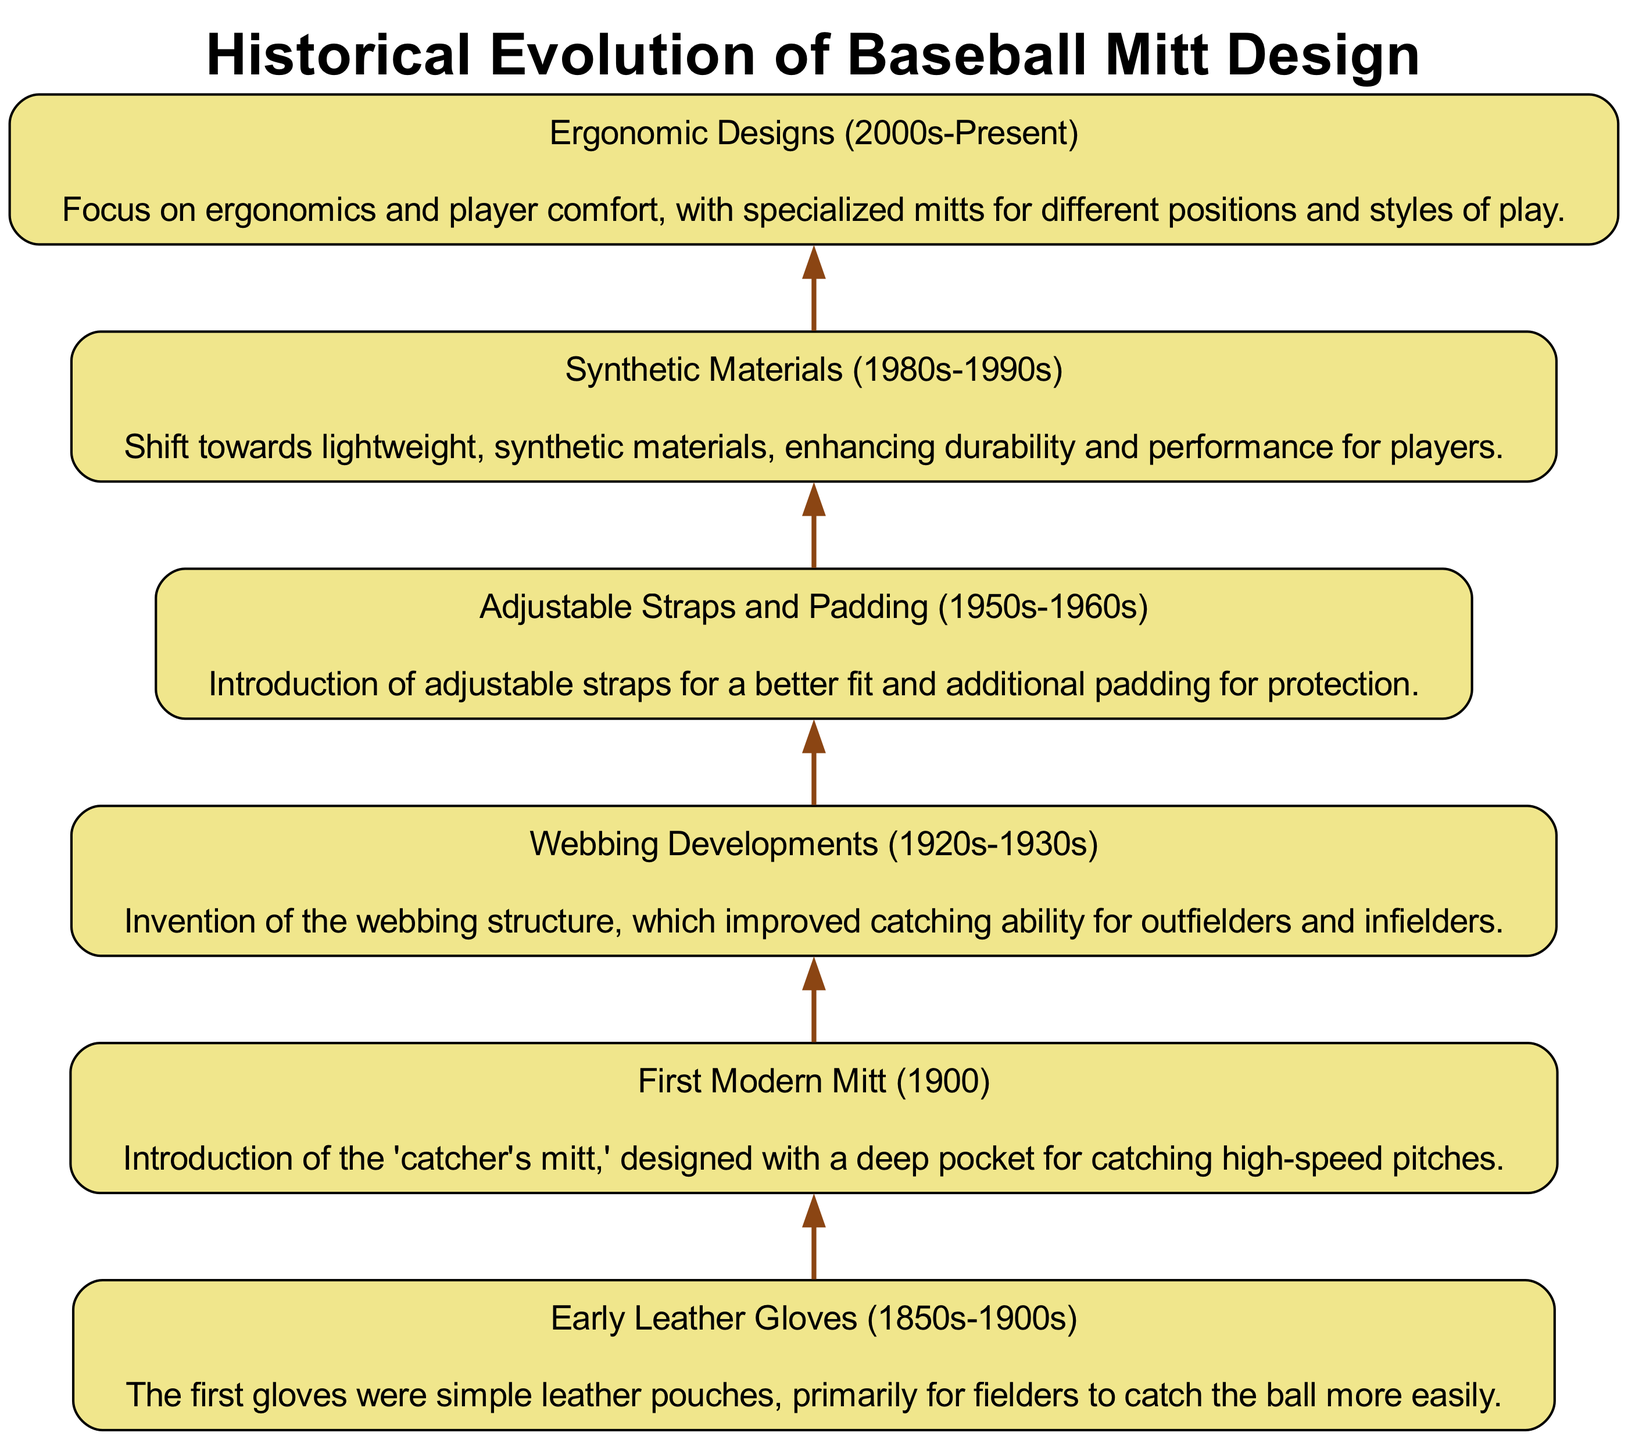What is the first style of baseball mitt listed in the diagram? The first element in the flowchart represents "Early Leather Gloves (1850s-1900s)," which is located at the top.
Answer: Early Leather Gloves (1850s-1900s) How many key styles of baseball mitt design are presented in the diagram? The diagram presents a total of six elements, each representing a key style.
Answer: 6 What was introduced in the year 1900 according to the flowchart? The second element identifies "First Modern Mitt (1900)," which indicates the introduction of the catcher's mitt during that year.
Answer: First Modern Mitt (1900) What development occurred in the 1920s and 1930s? The flowchart shows that during this time, "Webbing Developments" occurred, improving catching ability.
Answer: Webbing Developments (1920s-1930s) Which mitt design feature was introduced in the 1950s-1960s? The chart indicates that "Adjustable Straps and Padding" were added to mitt designs during this period, improving fit and protection.
Answer: Adjustable Straps and Padding (1950s-1960s) How did the material of baseball mitts change in the 1980s-1990s? According to the diagram, there was a shift towards "Synthetic Materials," focusing on lightweight and durable options.
Answer: Synthetic Materials (1980s-1990s) What does the final element of the chart focus on? The last element emphasizes "Ergonomic Designs," indicating a modern focus on comfort and player-specific mitts.
Answer: Ergonomic Designs (2000s-Present) Which mitt design is related to enhanced durability? The element labeled "Synthetic Materials (1980s-1990s)" is directly related to increased durability through the use of synthetic materials.
Answer: Synthetic Materials (1980s-1990s) What is unique about the mitt designs from the 2000s to the present? The flowchart highlights that mitt designs from the 2000s to the present are characterized by a focus on ergonomics and comfort tailored to player needs.
Answer: Ergonomic Designs (2000s-Present) 